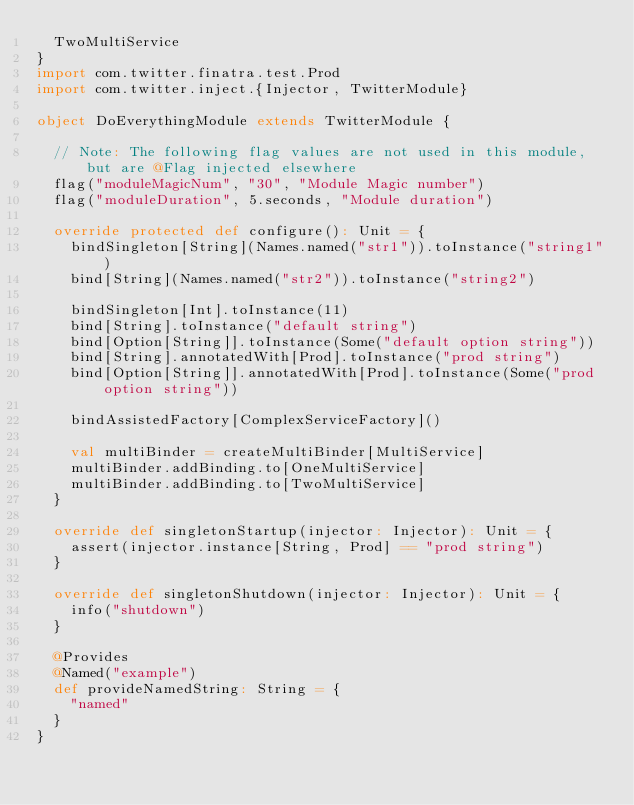<code> <loc_0><loc_0><loc_500><loc_500><_Scala_>  TwoMultiService
}
import com.twitter.finatra.test.Prod
import com.twitter.inject.{Injector, TwitterModule}

object DoEverythingModule extends TwitterModule {

  // Note: The following flag values are not used in this module, but are @Flag injected elsewhere
  flag("moduleMagicNum", "30", "Module Magic number")
  flag("moduleDuration", 5.seconds, "Module duration")

  override protected def configure(): Unit = {
    bindSingleton[String](Names.named("str1")).toInstance("string1")
    bind[String](Names.named("str2")).toInstance("string2")

    bindSingleton[Int].toInstance(11)
    bind[String].toInstance("default string")
    bind[Option[String]].toInstance(Some("default option string"))
    bind[String].annotatedWith[Prod].toInstance("prod string")
    bind[Option[String]].annotatedWith[Prod].toInstance(Some("prod option string"))

    bindAssistedFactory[ComplexServiceFactory]()

    val multiBinder = createMultiBinder[MultiService]
    multiBinder.addBinding.to[OneMultiService]
    multiBinder.addBinding.to[TwoMultiService]
  }

  override def singletonStartup(injector: Injector): Unit = {
    assert(injector.instance[String, Prod] == "prod string")
  }

  override def singletonShutdown(injector: Injector): Unit = {
    info("shutdown")
  }

  @Provides
  @Named("example")
  def provideNamedString: String = {
    "named"
  }
}
</code> 